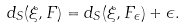Convert formula to latex. <formula><loc_0><loc_0><loc_500><loc_500>d _ { S } ( \xi , F ) = d _ { S } ( \xi , F _ { \epsilon } ) + \epsilon .</formula> 